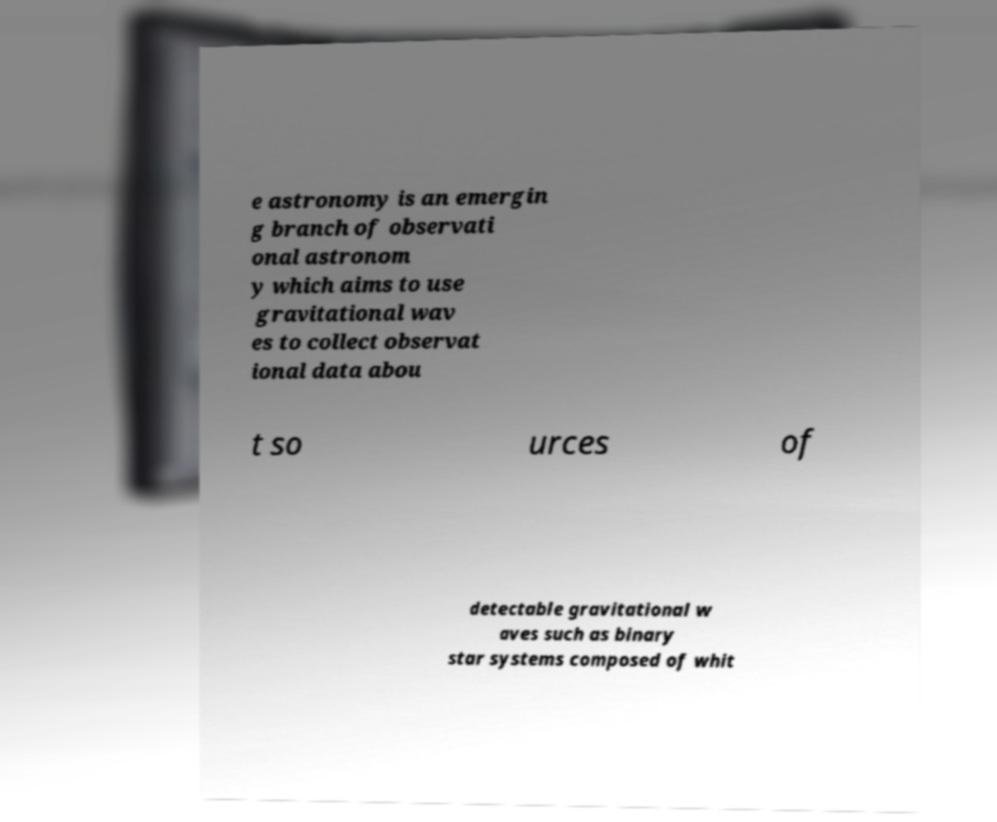Can you read and provide the text displayed in the image?This photo seems to have some interesting text. Can you extract and type it out for me? e astronomy is an emergin g branch of observati onal astronom y which aims to use gravitational wav es to collect observat ional data abou t so urces of detectable gravitational w aves such as binary star systems composed of whit 